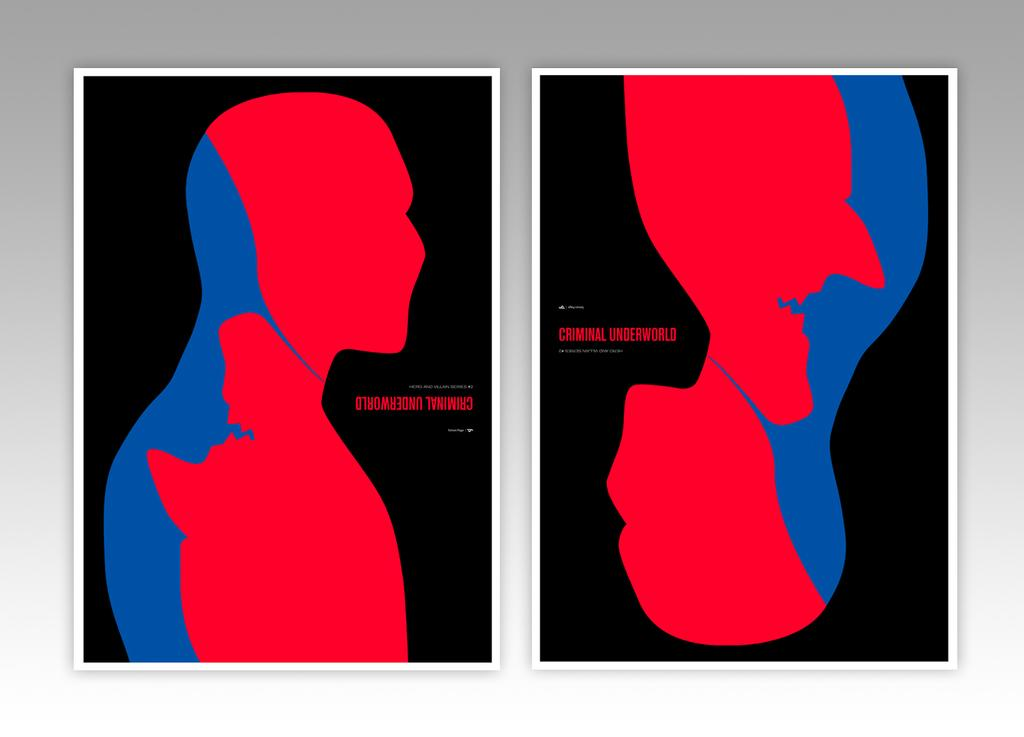What is the main subject of the image? The main subject of the image is two graphic images side by side. What is depicted in the graphic images? One person is depicted in the graphic images. What colors are used to represent the person in the graphic images? The person appears in red and blue colors. How many chairs are visible in the image? There are no chairs visible in the image; it features two graphic images side by side with a person depicted in red and blue colors. Can you describe the foot of the person in the image? There is no foot visible in the image, as it only shows two graphic images with a person depicted in red and blue colors. 